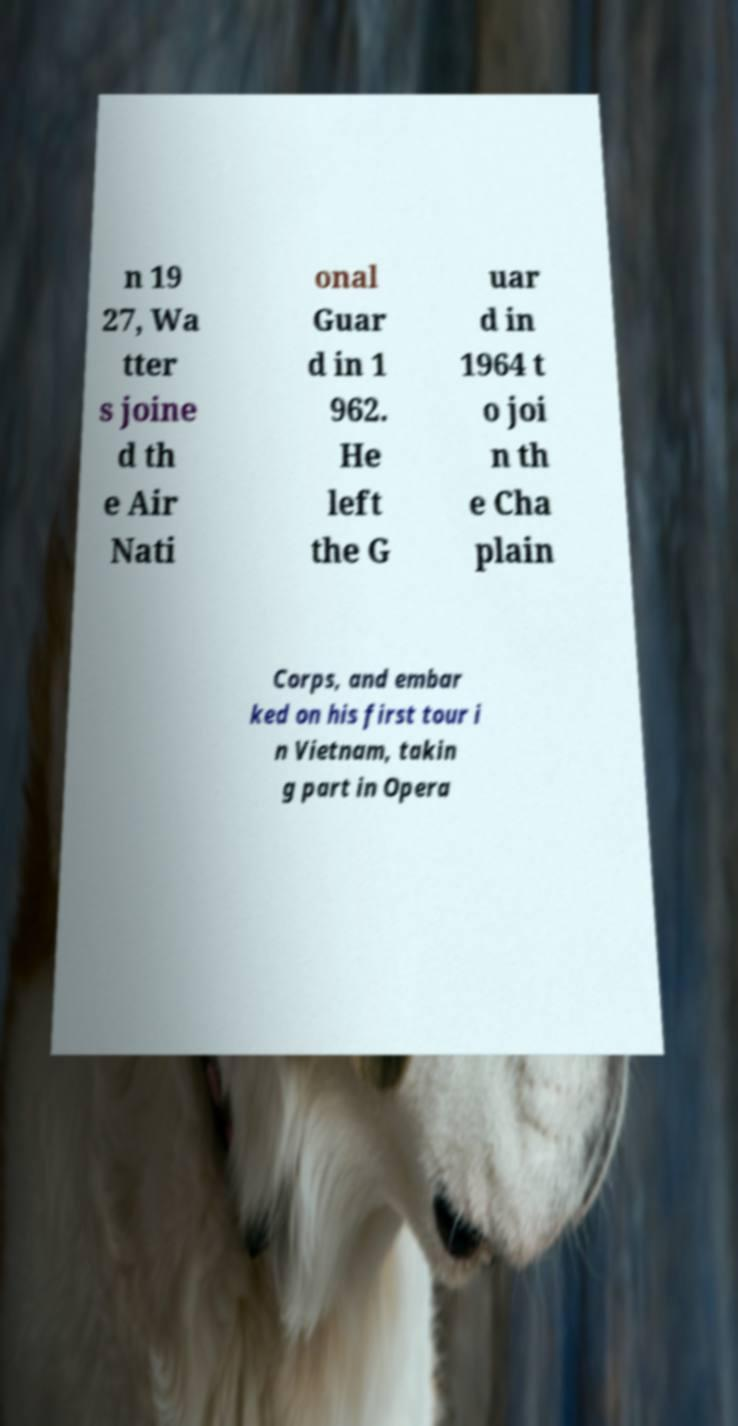Can you read and provide the text displayed in the image?This photo seems to have some interesting text. Can you extract and type it out for me? n 19 27, Wa tter s joine d th e Air Nati onal Guar d in 1 962. He left the G uar d in 1964 t o joi n th e Cha plain Corps, and embar ked on his first tour i n Vietnam, takin g part in Opera 